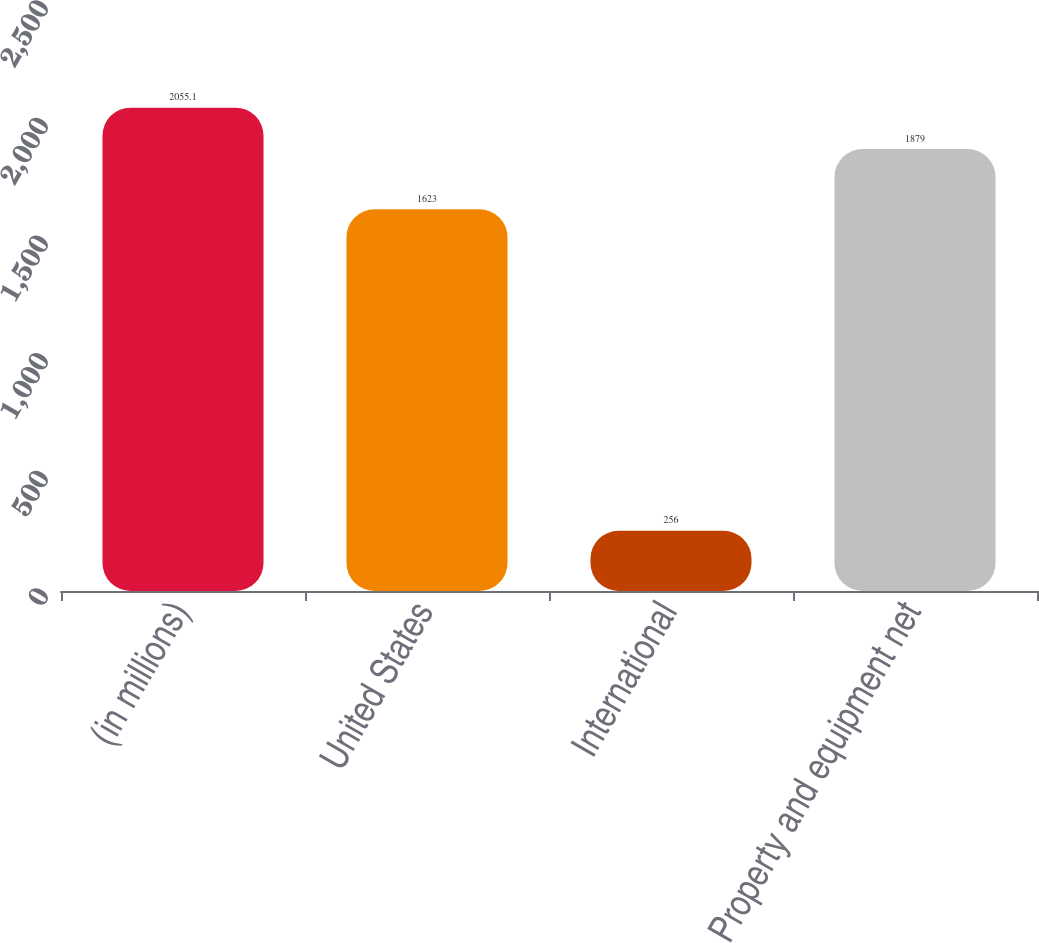<chart> <loc_0><loc_0><loc_500><loc_500><bar_chart><fcel>(in millions)<fcel>United States<fcel>International<fcel>Property and equipment net<nl><fcel>2055.1<fcel>1623<fcel>256<fcel>1879<nl></chart> 